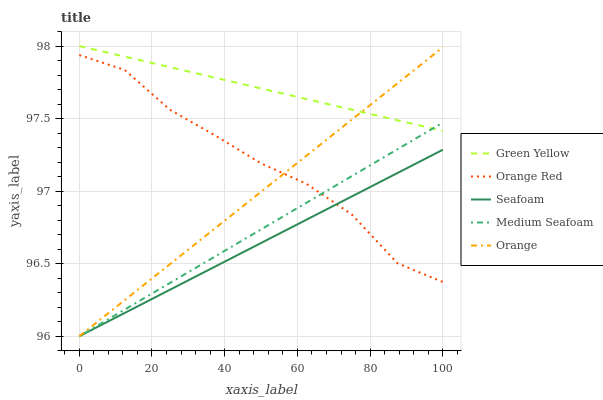Does Seafoam have the minimum area under the curve?
Answer yes or no. Yes. Does Green Yellow have the maximum area under the curve?
Answer yes or no. Yes. Does Medium Seafoam have the minimum area under the curve?
Answer yes or no. No. Does Medium Seafoam have the maximum area under the curve?
Answer yes or no. No. Is Orange the smoothest?
Answer yes or no. Yes. Is Orange Red the roughest?
Answer yes or no. Yes. Is Medium Seafoam the smoothest?
Answer yes or no. No. Is Medium Seafoam the roughest?
Answer yes or no. No. Does Orange have the lowest value?
Answer yes or no. Yes. Does Green Yellow have the lowest value?
Answer yes or no. No. Does Green Yellow have the highest value?
Answer yes or no. Yes. Does Medium Seafoam have the highest value?
Answer yes or no. No. Is Orange Red less than Green Yellow?
Answer yes or no. Yes. Is Green Yellow greater than Seafoam?
Answer yes or no. Yes. Does Medium Seafoam intersect Green Yellow?
Answer yes or no. Yes. Is Medium Seafoam less than Green Yellow?
Answer yes or no. No. Is Medium Seafoam greater than Green Yellow?
Answer yes or no. No. Does Orange Red intersect Green Yellow?
Answer yes or no. No. 